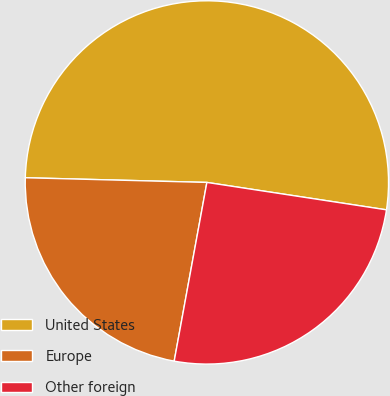Convert chart to OTSL. <chart><loc_0><loc_0><loc_500><loc_500><pie_chart><fcel>United States<fcel>Europe<fcel>Other foreign<nl><fcel>52.0%<fcel>22.53%<fcel>25.47%<nl></chart> 